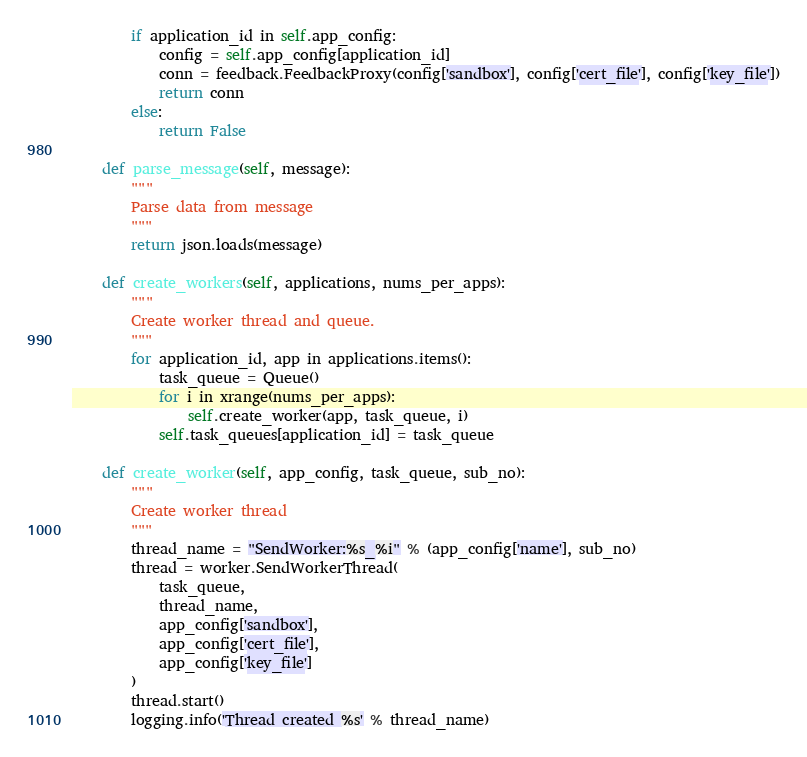Convert code to text. <code><loc_0><loc_0><loc_500><loc_500><_Python_>        if application_id in self.app_config:
            config = self.app_config[application_id]
            conn = feedback.FeedbackProxy(config['sandbox'], config['cert_file'], config['key_file'])
            return conn
        else:
            return False

    def parse_message(self, message):
        """
        Parse data from message
        """
        return json.loads(message)

    def create_workers(self, applications, nums_per_apps):
        """
        Create worker thread and queue.
        """
        for application_id, app in applications.items():
            task_queue = Queue()
            for i in xrange(nums_per_apps):
                self.create_worker(app, task_queue, i)
            self.task_queues[application_id] = task_queue

    def create_worker(self, app_config, task_queue, sub_no):
        """
        Create worker thread
        """
        thread_name = "SendWorker:%s_%i" % (app_config['name'], sub_no)
        thread = worker.SendWorkerThread(
            task_queue,
            thread_name,
            app_config['sandbox'],
            app_config['cert_file'],
            app_config['key_file']
        )
        thread.start()
        logging.info('Thread created %s' % thread_name)
</code> 